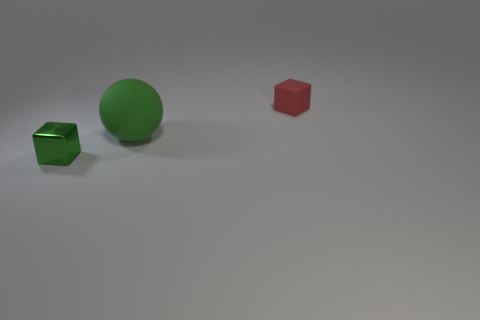There is a shiny object that is the same color as the big matte sphere; what size is it?
Ensure brevity in your answer.  Small. Does the green thing right of the small green thing have the same shape as the red thing?
Make the answer very short. No. What number of cubes are both in front of the large green ball and right of the small metal thing?
Offer a terse response. 0. What number of other objects are there of the same size as the red rubber thing?
Provide a succinct answer. 1. Are there an equal number of tiny red rubber cubes in front of the big rubber ball and yellow shiny cylinders?
Your answer should be very brief. Yes. Does the cube behind the shiny thing have the same color as the tiny object that is in front of the red cube?
Your response must be concise. No. The thing that is in front of the small red cube and behind the metallic block is made of what material?
Your response must be concise. Rubber. What is the color of the rubber cube?
Ensure brevity in your answer.  Red. What number of other objects are the same shape as the big green matte thing?
Provide a succinct answer. 0. Is the number of tiny green blocks on the right side of the matte sphere the same as the number of rubber blocks that are right of the metal object?
Provide a short and direct response. No. 